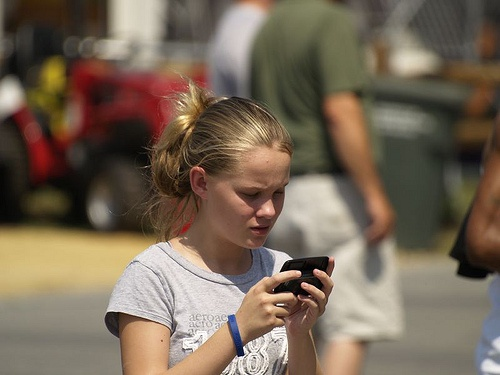Describe the objects in this image and their specific colors. I can see people in gray, lightgray, and maroon tones, people in gray, darkgreen, darkgray, and lightgray tones, people in gray, black, and maroon tones, people in gray, darkgray, and lightgray tones, and cell phone in gray, black, and maroon tones in this image. 